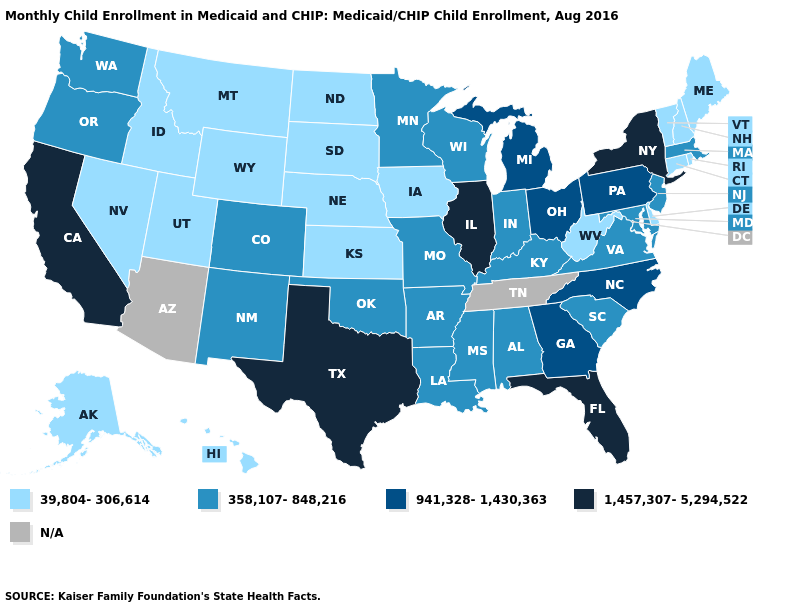Which states have the lowest value in the USA?
Write a very short answer. Alaska, Connecticut, Delaware, Hawaii, Idaho, Iowa, Kansas, Maine, Montana, Nebraska, Nevada, New Hampshire, North Dakota, Rhode Island, South Dakota, Utah, Vermont, West Virginia, Wyoming. Does New York have the highest value in the Northeast?
Write a very short answer. Yes. Does New Hampshire have the highest value in the Northeast?
Be succinct. No. Name the states that have a value in the range 1,457,307-5,294,522?
Concise answer only. California, Florida, Illinois, New York, Texas. What is the value of Louisiana?
Concise answer only. 358,107-848,216. What is the lowest value in states that border Minnesota?
Short answer required. 39,804-306,614. What is the value of Ohio?
Be succinct. 941,328-1,430,363. What is the highest value in states that border Colorado?
Give a very brief answer. 358,107-848,216. Among the states that border South Dakota , which have the lowest value?
Short answer required. Iowa, Montana, Nebraska, North Dakota, Wyoming. What is the value of Illinois?
Answer briefly. 1,457,307-5,294,522. Does the map have missing data?
Short answer required. Yes. What is the value of Wisconsin?
Give a very brief answer. 358,107-848,216. Does Ohio have the lowest value in the MidWest?
Give a very brief answer. No. 